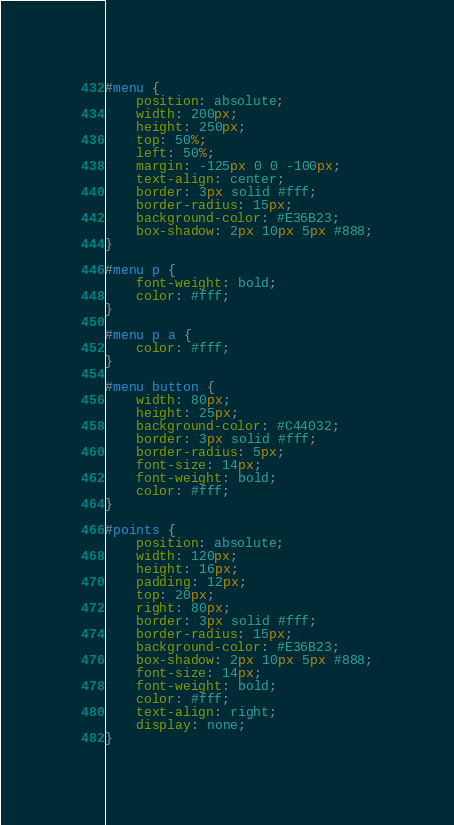<code> <loc_0><loc_0><loc_500><loc_500><_CSS_>#menu {
    position: absolute;
    width: 200px;
    height: 250px;
    top: 50%;
    left: 50%;
    margin: -125px 0 0 -100px;
    text-align: center;
    border: 3px solid #fff;
    border-radius: 15px;
    background-color: #E36B23;
    box-shadow: 2px 10px 5px #888;
}

#menu p {
    font-weight: bold;
    color: #fff;
}

#menu p a {
    color: #fff;
}

#menu button {
    width: 80px;
    height: 25px;
    background-color: #C44032;
    border: 3px solid #fff;
    border-radius: 5px;
    font-size: 14px;
    font-weight: bold;
    color: #fff;
}

#points {
    position: absolute;
    width: 120px;
    height: 16px;
    padding: 12px;
    top: 20px;
    right: 80px;
    border: 3px solid #fff;
    border-radius: 15px;
    background-color: #E36B23;
    box-shadow: 2px 10px 5px #888;
    font-size: 14px;
    font-weight: bold;
    color: #fff;
    text-align: right;
    display: none;
}</code> 